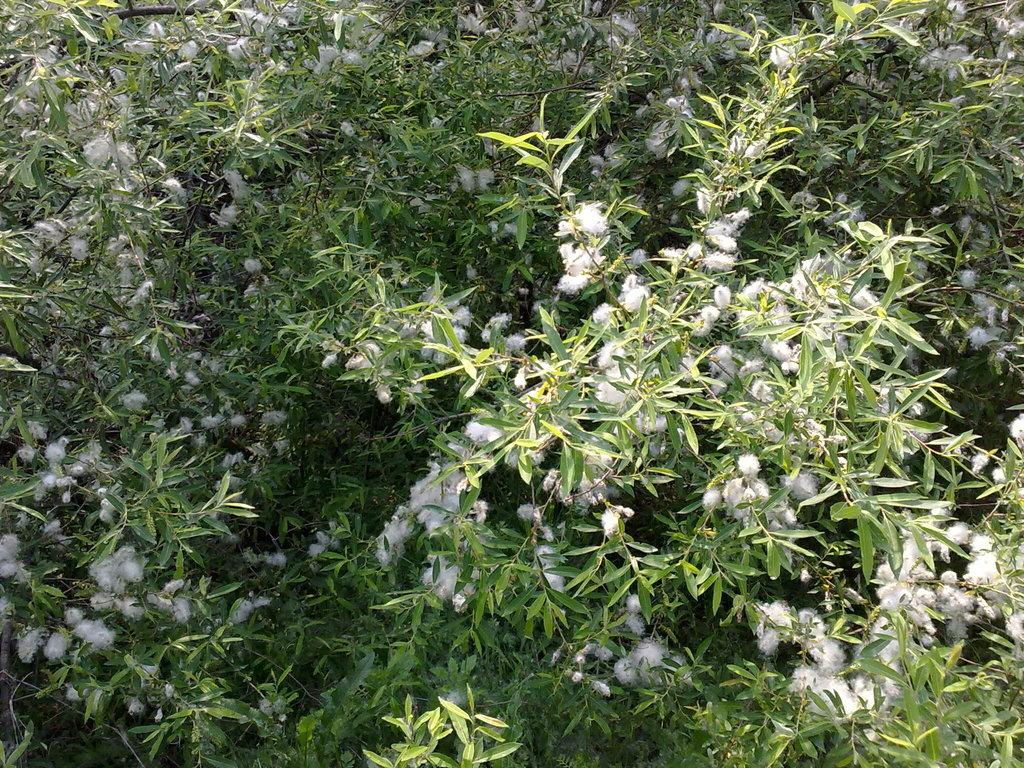What type of living organisms can be seen in the image? Plants can be seen in the image. What features are present on the plants in the image? The plants have flowers and leaves. What type of health benefits can be gained from the plants in the image? The image does not provide information about the specific type of plants or their potential health benefits, so it cannot be determined from the image. 